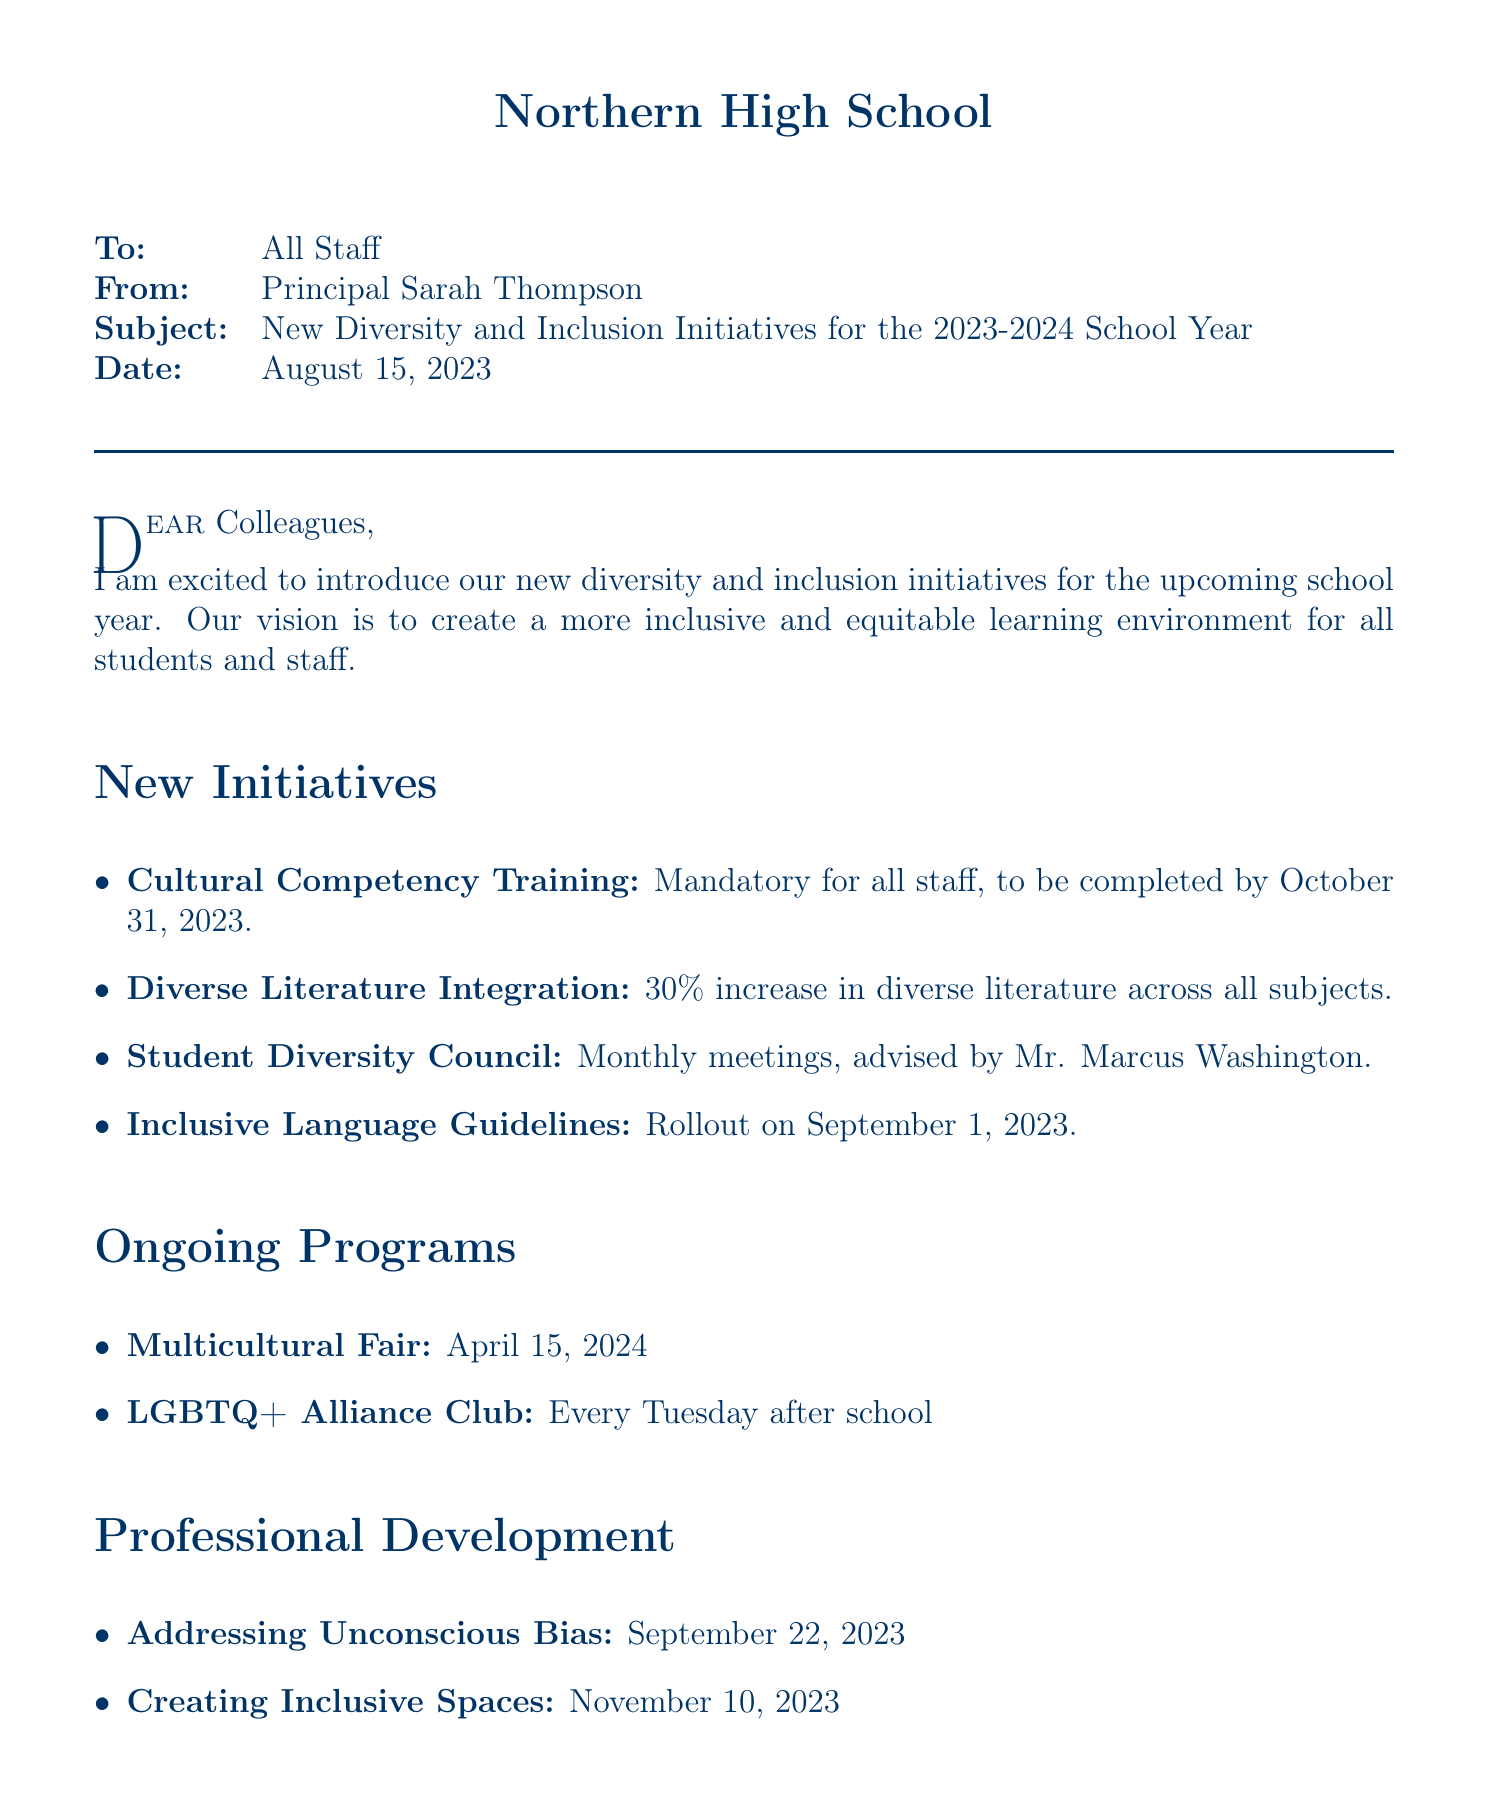what is the purpose of the memo? The purpose of the memo is to introduce new diversity and inclusion initiatives for the school.
Answer: To introduce new diversity and inclusion initiatives for our school who is the provider of the Cultural Competency Training? The provider of the Cultural Competency Training is the National Equity Project.
Answer: National Equity Project what is the goal for Diverse Literature Integration? The goal is a 30% increase in diverse literature across all subjects by the end of the school year.
Answer: 30% increase in diverse literature across all subjects by the end of the school year when will the Inclusive Language Guidelines be rolled out? The Inclusive Language Guidelines will be rolled out on September 1, 2023.
Answer: September 1, 2023 how often will the Student Diversity Council meet? The Student Diversity Council will meet monthly.
Answer: Monthly who is the advisor for the LGBTQ+ Alliance Club? The advisor for the LGBTQ+ Alliance Club is Mx. Alex Nguyen.
Answer: Mx. Alex Nguyen what is located in Room 205? The Diversity and Inclusion Resource Center is located in Room 205.
Answer: Diversity and Inclusion Resource Center what is the message in the closing remarks? The message in the closing remarks is about creating a more inclusive and equitable learning environment for all students.
Answer: Together, we can create a more inclusive and equitable learning environment that prepares all our students for success in a diverse world 